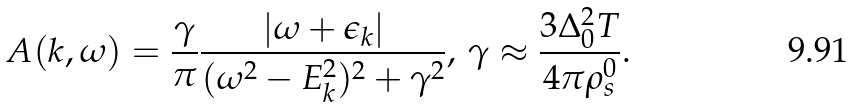<formula> <loc_0><loc_0><loc_500><loc_500>A ( { k } , \omega ) = \frac { \gamma } { \pi } \frac { | \omega + \epsilon _ { k } | } { ( \omega ^ { 2 } - E _ { k } ^ { 2 } ) ^ { 2 } + \gamma ^ { 2 } } , \, \gamma \approx \frac { 3 \Delta _ { 0 } ^ { 2 } T } { 4 \pi \rho _ { s } ^ { 0 } } .</formula> 